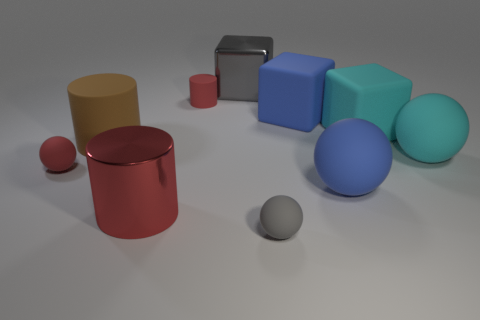Subtract all brown spheres. Subtract all yellow cylinders. How many spheres are left? 4 Subtract all balls. How many objects are left? 6 Add 2 tiny matte balls. How many tiny matte balls exist? 4 Subtract 0 brown balls. How many objects are left? 10 Subtract all cyan matte cubes. Subtract all green shiny cylinders. How many objects are left? 9 Add 6 big brown cylinders. How many big brown cylinders are left? 7 